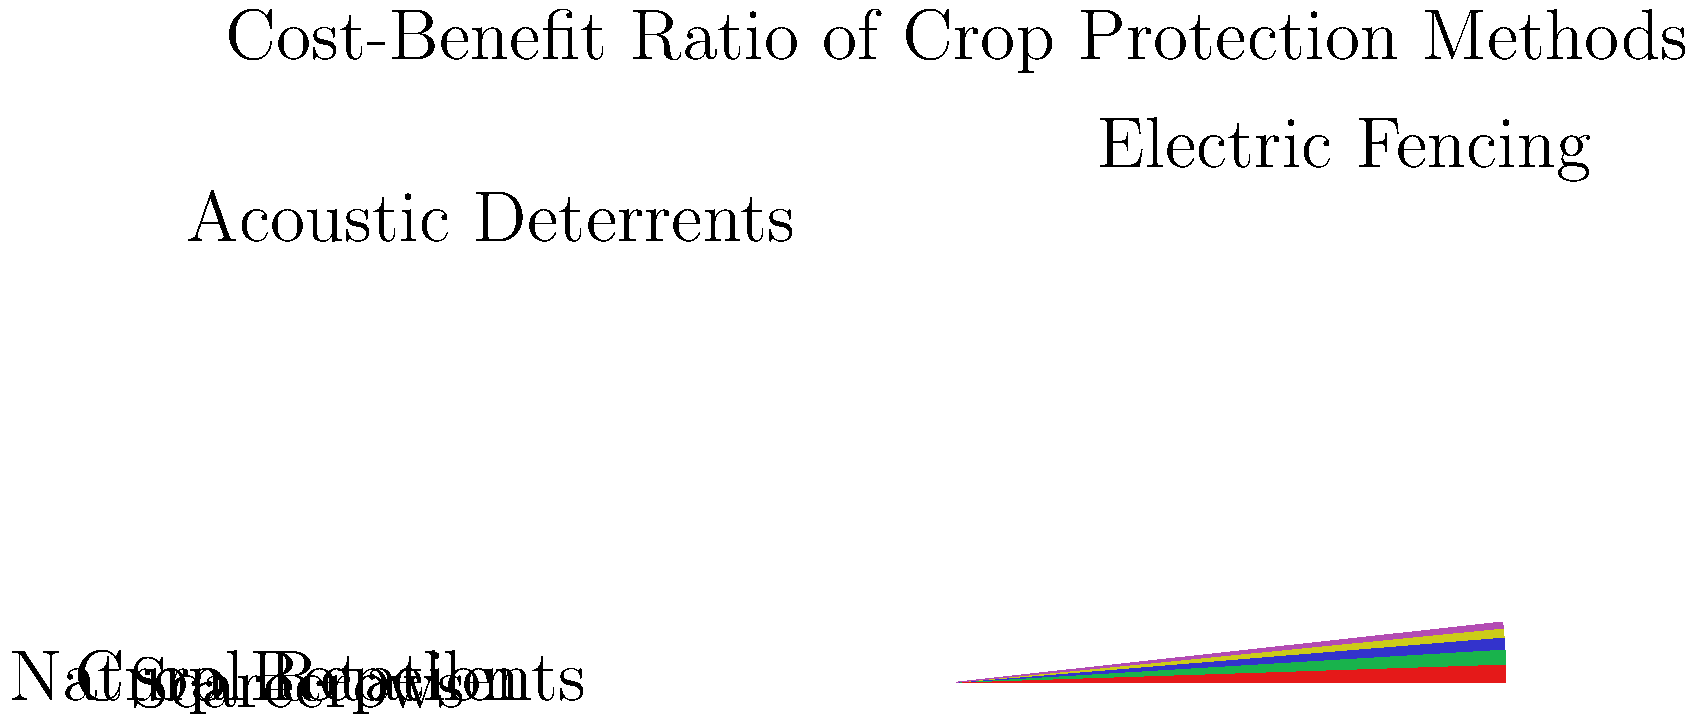Based on the pie chart showing the cost-benefit ratio of various crop protection methods, which method appears to have the highest return on investment for long-term crop protection? To determine the method with the highest return on investment, we need to analyze the pie chart:

1. The chart shows five different crop protection methods:
   - Electric Fencing
   - Acoustic Deterrents
   - Crop Rotation
   - Natural Repellents
   - Scarecrows

2. The size of each slice represents the cost-benefit ratio for each method.

3. A larger slice indicates a higher cost-benefit ratio, meaning better return on investment.

4. Examining the chart, we can see that:
   - Electric Fencing has the largest slice, occupying approximately 30% of the pie.
   - Acoustic Deterrents is the second-largest, with about 25%.
   - Crop Rotation is third, with roughly 20%.
   - Natural Repellents and Scarecrows have smaller slices.

5. Since Electric Fencing has the largest slice, it represents the highest cost-benefit ratio among the methods shown.

Therefore, based on this data, Electric Fencing appears to have the highest return on investment for long-term crop protection.
Answer: Electric Fencing 